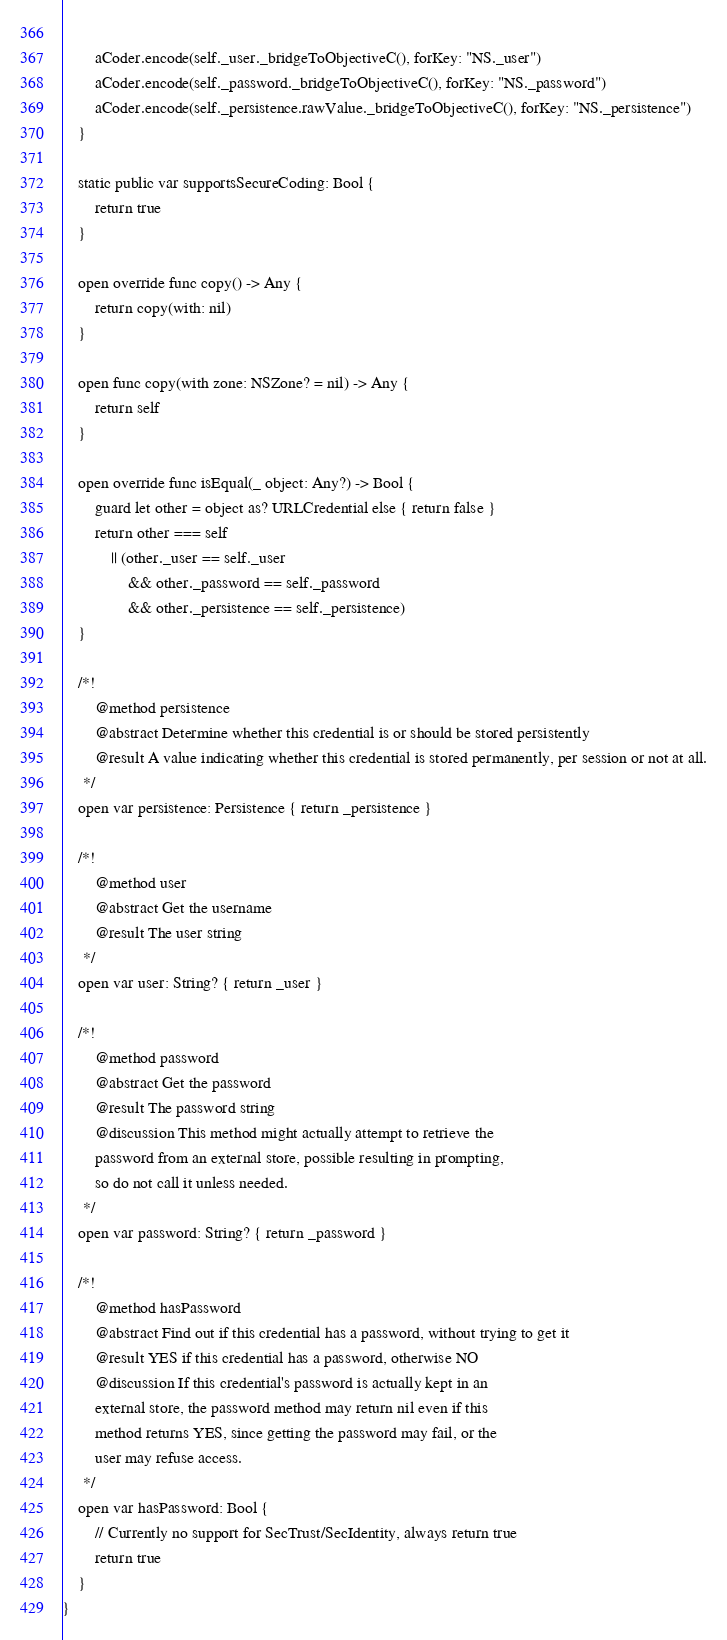Convert code to text. <code><loc_0><loc_0><loc_500><loc_500><_Swift_>        
        aCoder.encode(self._user._bridgeToObjectiveC(), forKey: "NS._user")
        aCoder.encode(self._password._bridgeToObjectiveC(), forKey: "NS._password")
        aCoder.encode(self._persistence.rawValue._bridgeToObjectiveC(), forKey: "NS._persistence")
    }
    
    static public var supportsSecureCoding: Bool {
        return true
    }
    
    open override func copy() -> Any {
        return copy(with: nil)
    }
    
    open func copy(with zone: NSZone? = nil) -> Any {
        return self 
    }
    
    open override func isEqual(_ object: Any?) -> Bool {
        guard let other = object as? URLCredential else { return false }
        return other === self
            || (other._user == self._user
                && other._password == self._password
                && other._persistence == self._persistence)
    }
    
    /*!
        @method persistence
        @abstract Determine whether this credential is or should be stored persistently
        @result A value indicating whether this credential is stored permanently, per session or not at all.
     */
    open var persistence: Persistence { return _persistence }
    
    /*!
        @method user
        @abstract Get the username
        @result The user string
     */
    open var user: String? { return _user }
    
    /*!
        @method password
        @abstract Get the password
        @result The password string
        @discussion This method might actually attempt to retrieve the
        password from an external store, possible resulting in prompting,
        so do not call it unless needed.
     */
    open var password: String? { return _password }

    /*!
        @method hasPassword
        @abstract Find out if this credential has a password, without trying to get it
        @result YES if this credential has a password, otherwise NO
        @discussion If this credential's password is actually kept in an
        external store, the password method may return nil even if this
        method returns YES, since getting the password may fail, or the
        user may refuse access.
     */
    open var hasPassword: Bool {
        // Currently no support for SecTrust/SecIdentity, always return true
        return true
    }
}
</code> 